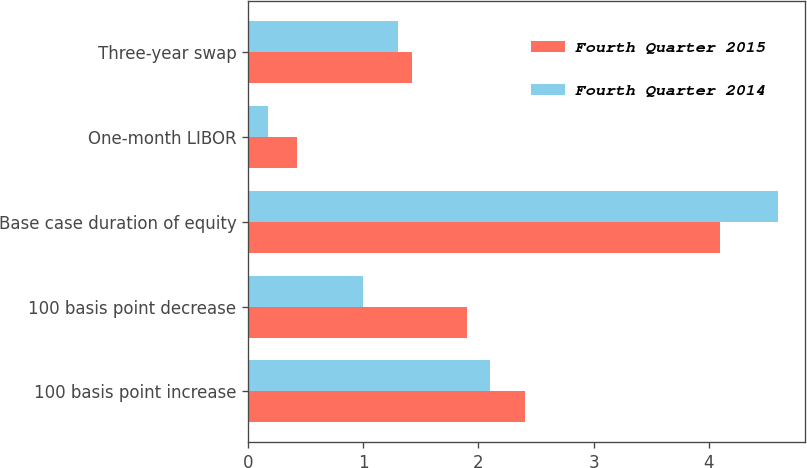Convert chart to OTSL. <chart><loc_0><loc_0><loc_500><loc_500><stacked_bar_chart><ecel><fcel>100 basis point increase<fcel>100 basis point decrease<fcel>Base case duration of equity<fcel>One-month LIBOR<fcel>Three-year swap<nl><fcel>Fourth Quarter 2015<fcel>2.4<fcel>1.9<fcel>4.1<fcel>0.43<fcel>1.42<nl><fcel>Fourth Quarter 2014<fcel>2.1<fcel>1<fcel>4.6<fcel>0.17<fcel>1.3<nl></chart> 